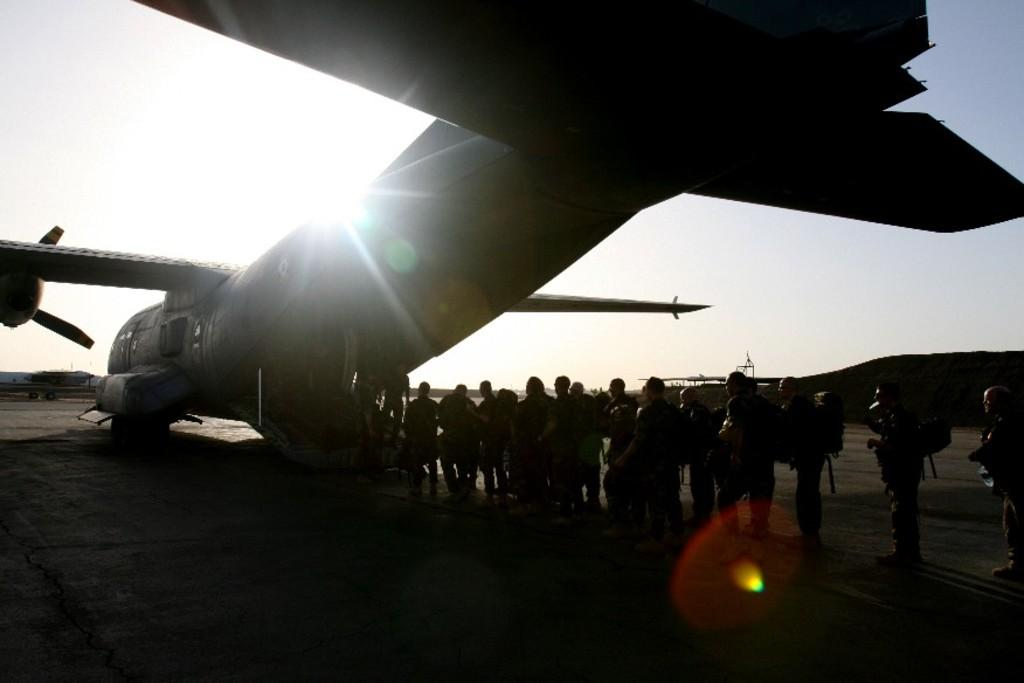What is the main subject of subject of the image? The main subject of the image is an aircraft. Can you describe the surroundings of the aircraft? There are many people standing on the road, and there is another aircraft on the left side of the image. What can be seen in the sky in the image? The sky is visible at the top of the image. Are there any visible nails or icicles hanging from the aircraft in the image? No, there are no visible nails or icicles hanging from the aircraft in the image. 